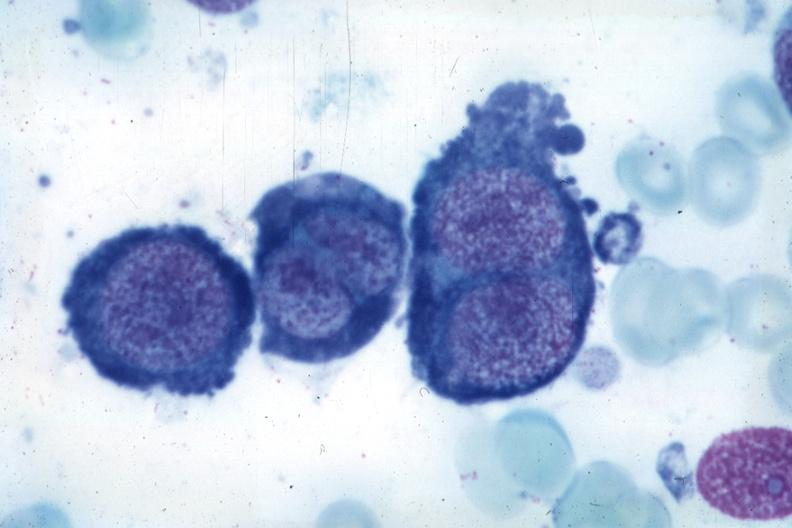does right side atresia show wrights typical cells?
Answer the question using a single word or phrase. No 